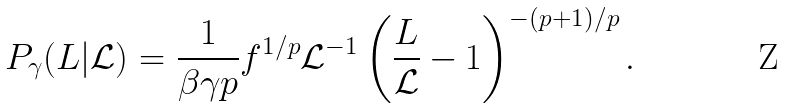Convert formula to latex. <formula><loc_0><loc_0><loc_500><loc_500>P _ { \gamma } ( L | \mathcal { L } ) = \frac { 1 } { \beta \gamma p } f ^ { 1 / p } \mathcal { L } ^ { - 1 } \left ( \frac { L } { \mathcal { L } } - 1 \right ) ^ { - ( p + 1 ) / p } .</formula> 